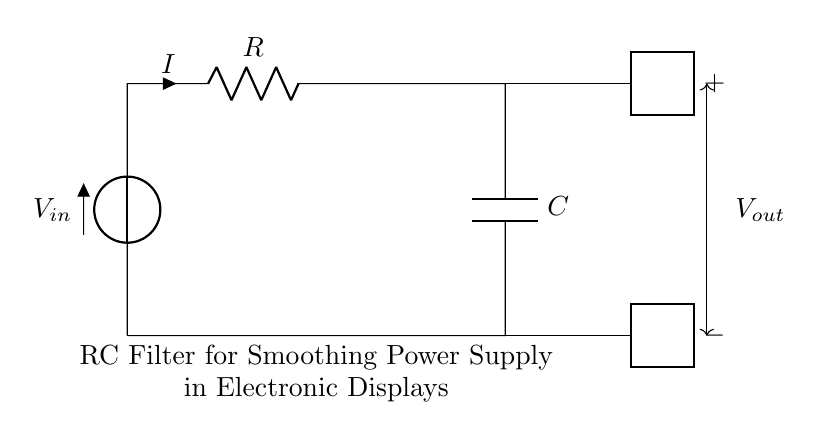What is the power supply voltage? The power supply voltage is denoted as V_in in the circuit diagram, typically representing the input voltage that powers the circuit.
Answer: V_in What component is used for filtering? The component used for filtering in this circuit is a capacitor, as indicated by the symbol labeled C connecting the output line to ground.
Answer: Capacitor What is the purpose of the resistor in this circuit? The resistor, labeled R, is used to limit the current flowing into the capacitor and, along with the capacitor, forms a low-pass filter for smoothing out the voltage.
Answer: Limit current How does the capacitor behave in this circuit? In this RC filter circuit, the capacitor charges and discharges, smoothing out voltage fluctuations by storing energy and releasing it slowly to the load.
Answer: Smooth voltage What happens to the output voltage during sudden input changes? When there are sudden changes in the input voltage, the output voltage V_out will change more gradually due to the charging and discharging characteristics of the capacitor.
Answer: Gradual change What type of filter is this RC configuration? This configuration acts as a low-pass filter, allowing low frequency signals to pass while attenuating high frequency signals.
Answer: Low-pass filter What is the relationship between resistance and capacitance in this circuit? The relationship is described by the time constant τ, given by τ = R*C, which determines how quickly the capacitor charges and discharges in response to changes in the input voltage.
Answer: Time constant 